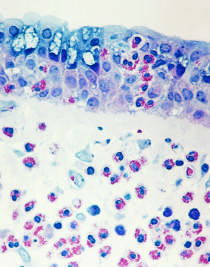what is characterized by an inflammatory infiltrate rich in eosinophils, neutrophils, and t cells?
Answer the question using a single word or phrase. The late-phase reaction 